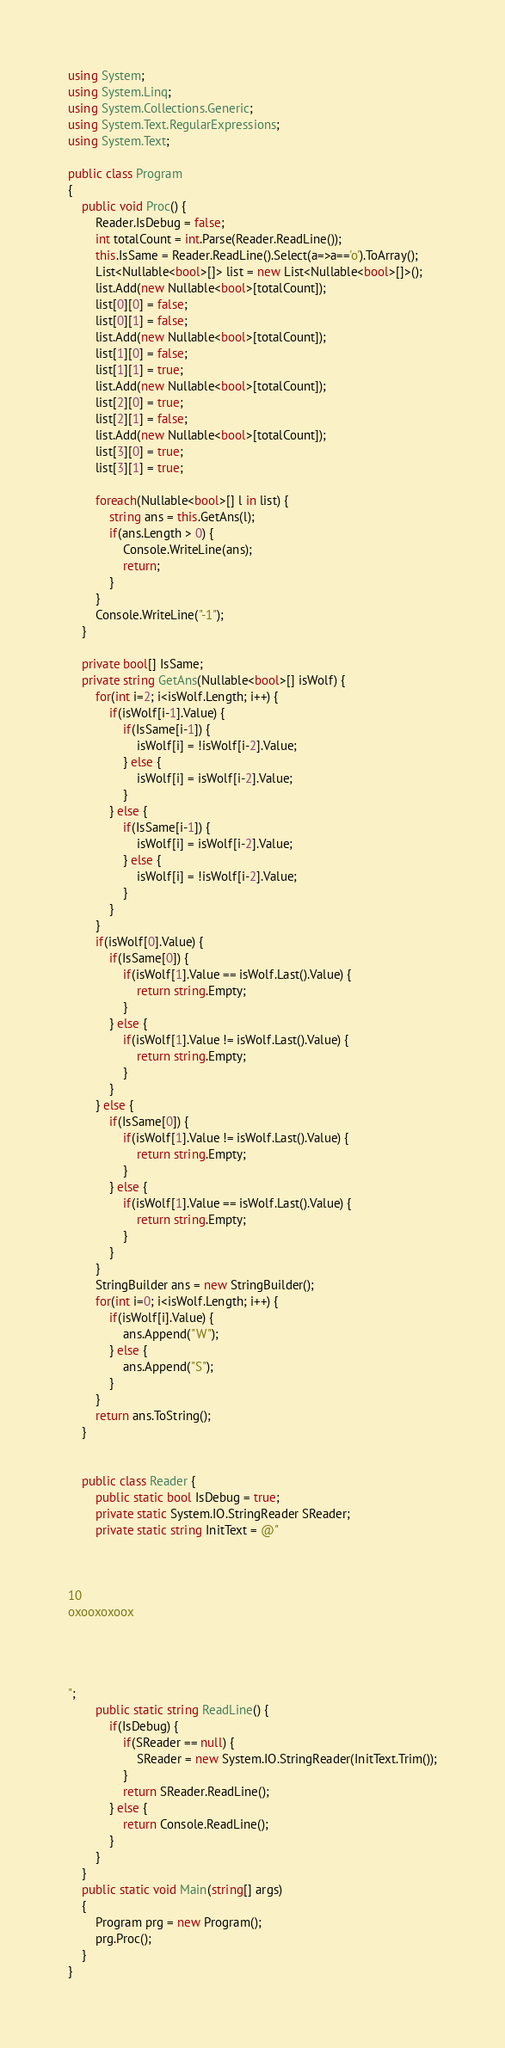Convert code to text. <code><loc_0><loc_0><loc_500><loc_500><_C#_>using System;
using System.Linq;
using System.Collections.Generic;
using System.Text.RegularExpressions;
using System.Text;
 
public class Program
{
    public void Proc() {
        Reader.IsDebug = false;
        int totalCount = int.Parse(Reader.ReadLine());
        this.IsSame = Reader.ReadLine().Select(a=>a=='o').ToArray();
        List<Nullable<bool>[]> list = new List<Nullable<bool>[]>();
        list.Add(new Nullable<bool>[totalCount]);
        list[0][0] = false;
        list[0][1] = false;
        list.Add(new Nullable<bool>[totalCount]);
        list[1][0] = false;
        list[1][1] = true;
        list.Add(new Nullable<bool>[totalCount]);
        list[2][0] = true;
        list[2][1] = false;
        list.Add(new Nullable<bool>[totalCount]);
        list[3][0] = true;
        list[3][1] = true;

        foreach(Nullable<bool>[] l in list) {
            string ans = this.GetAns(l);
            if(ans.Length > 0) {
                Console.WriteLine(ans);
                return;
            }
        }
        Console.WriteLine("-1");
    }

    private bool[] IsSame;
    private string GetAns(Nullable<bool>[] isWolf) {
        for(int i=2; i<isWolf.Length; i++) {
            if(isWolf[i-1].Value) {
                if(IsSame[i-1]) {
                    isWolf[i] = !isWolf[i-2].Value;
                } else {
                    isWolf[i] = isWolf[i-2].Value;
                }
            } else {
                if(IsSame[i-1]) {
                    isWolf[i] = isWolf[i-2].Value;
                } else {
                    isWolf[i] = !isWolf[i-2].Value;
                }
            }
        }
        if(isWolf[0].Value) {
            if(IsSame[0]) {
                if(isWolf[1].Value == isWolf.Last().Value) {
                    return string.Empty;
                }
            } else {
                if(isWolf[1].Value != isWolf.Last().Value) {
                    return string.Empty;
                }                
            }
        } else {
            if(IsSame[0]) {
                if(isWolf[1].Value != isWolf.Last().Value) {
                    return string.Empty;
                }
            } else {
                if(isWolf[1].Value == isWolf.Last().Value) {
                    return string.Empty;
                }                
            }
        }
        StringBuilder ans = new StringBuilder();
        for(int i=0; i<isWolf.Length; i++) {
            if(isWolf[i].Value) {
                ans.Append("W");
            } else {
                ans.Append("S");
            }
        }
        return ans.ToString();
    }


    public class Reader {
        public static bool IsDebug = true;
        private static System.IO.StringReader SReader;
        private static string InitText = @"



10
oxooxoxoox




";
        public static string ReadLine() {
            if(IsDebug) {
                if(SReader == null) {
                    SReader = new System.IO.StringReader(InitText.Trim());
                }
                return SReader.ReadLine();
            } else {
                return Console.ReadLine();
            }
        }
    }
    public static void Main(string[] args)
    {
        Program prg = new Program();
        prg.Proc();
    }
}
</code> 